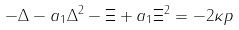Convert formula to latex. <formula><loc_0><loc_0><loc_500><loc_500>- \Delta - a _ { 1 } \Delta ^ { 2 } - \Xi + a _ { 1 } \Xi ^ { 2 } = - 2 \kappa p</formula> 